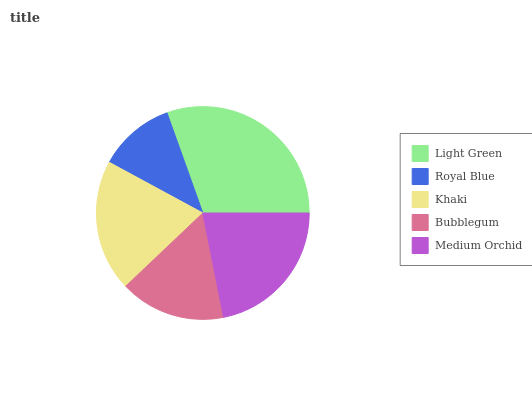Is Royal Blue the minimum?
Answer yes or no. Yes. Is Light Green the maximum?
Answer yes or no. Yes. Is Khaki the minimum?
Answer yes or no. No. Is Khaki the maximum?
Answer yes or no. No. Is Khaki greater than Royal Blue?
Answer yes or no. Yes. Is Royal Blue less than Khaki?
Answer yes or no. Yes. Is Royal Blue greater than Khaki?
Answer yes or no. No. Is Khaki less than Royal Blue?
Answer yes or no. No. Is Khaki the high median?
Answer yes or no. Yes. Is Khaki the low median?
Answer yes or no. Yes. Is Light Green the high median?
Answer yes or no. No. Is Bubblegum the low median?
Answer yes or no. No. 